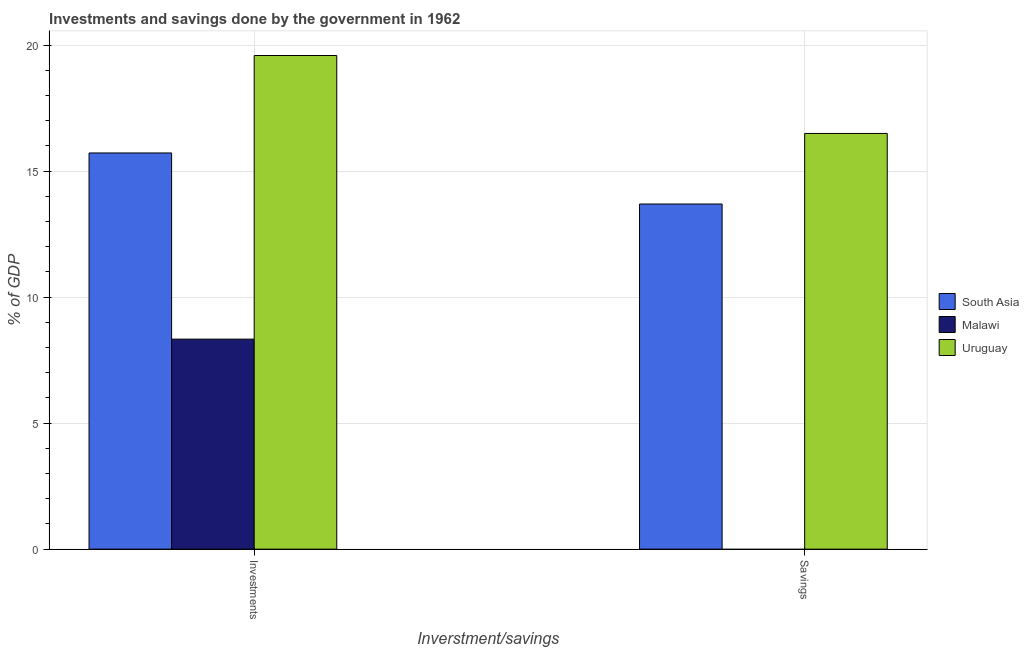How many different coloured bars are there?
Your response must be concise. 3. Are the number of bars per tick equal to the number of legend labels?
Keep it short and to the point. No. Are the number of bars on each tick of the X-axis equal?
Give a very brief answer. No. How many bars are there on the 2nd tick from the left?
Make the answer very short. 2. What is the label of the 2nd group of bars from the left?
Offer a terse response. Savings. What is the savings of government in Uruguay?
Your response must be concise. 16.49. Across all countries, what is the maximum savings of government?
Make the answer very short. 16.49. Across all countries, what is the minimum savings of government?
Provide a succinct answer. 0. In which country was the savings of government maximum?
Provide a short and direct response. Uruguay. What is the total savings of government in the graph?
Your answer should be very brief. 30.19. What is the difference between the investments of government in Uruguay and that in South Asia?
Ensure brevity in your answer.  3.87. What is the difference between the investments of government in Malawi and the savings of government in South Asia?
Provide a succinct answer. -5.36. What is the average savings of government per country?
Keep it short and to the point. 10.06. What is the difference between the investments of government and savings of government in Uruguay?
Your answer should be compact. 3.09. In how many countries, is the investments of government greater than 5 %?
Offer a very short reply. 3. What is the ratio of the investments of government in Uruguay to that in South Asia?
Offer a terse response. 1.25. In how many countries, is the savings of government greater than the average savings of government taken over all countries?
Ensure brevity in your answer.  2. What is the difference between two consecutive major ticks on the Y-axis?
Ensure brevity in your answer.  5. Does the graph contain grids?
Keep it short and to the point. Yes. What is the title of the graph?
Your answer should be compact. Investments and savings done by the government in 1962. What is the label or title of the X-axis?
Keep it short and to the point. Inverstment/savings. What is the label or title of the Y-axis?
Provide a succinct answer. % of GDP. What is the % of GDP in South Asia in Investments?
Give a very brief answer. 15.72. What is the % of GDP of Malawi in Investments?
Provide a succinct answer. 8.33. What is the % of GDP of Uruguay in Investments?
Your response must be concise. 19.59. What is the % of GDP of South Asia in Savings?
Provide a short and direct response. 13.69. What is the % of GDP in Malawi in Savings?
Provide a succinct answer. 0. What is the % of GDP of Uruguay in Savings?
Make the answer very short. 16.49. Across all Inverstment/savings, what is the maximum % of GDP of South Asia?
Ensure brevity in your answer.  15.72. Across all Inverstment/savings, what is the maximum % of GDP in Malawi?
Ensure brevity in your answer.  8.33. Across all Inverstment/savings, what is the maximum % of GDP of Uruguay?
Keep it short and to the point. 19.59. Across all Inverstment/savings, what is the minimum % of GDP in South Asia?
Your answer should be very brief. 13.69. Across all Inverstment/savings, what is the minimum % of GDP of Malawi?
Ensure brevity in your answer.  0. Across all Inverstment/savings, what is the minimum % of GDP in Uruguay?
Make the answer very short. 16.49. What is the total % of GDP of South Asia in the graph?
Provide a succinct answer. 29.42. What is the total % of GDP of Malawi in the graph?
Your answer should be very brief. 8.33. What is the total % of GDP of Uruguay in the graph?
Your answer should be very brief. 36.08. What is the difference between the % of GDP in South Asia in Investments and that in Savings?
Offer a very short reply. 2.03. What is the difference between the % of GDP in Uruguay in Investments and that in Savings?
Provide a succinct answer. 3.09. What is the difference between the % of GDP in South Asia in Investments and the % of GDP in Uruguay in Savings?
Offer a terse response. -0.77. What is the difference between the % of GDP of Malawi in Investments and the % of GDP of Uruguay in Savings?
Offer a terse response. -8.16. What is the average % of GDP in South Asia per Inverstment/savings?
Provide a short and direct response. 14.71. What is the average % of GDP of Malawi per Inverstment/savings?
Your response must be concise. 4.17. What is the average % of GDP in Uruguay per Inverstment/savings?
Provide a short and direct response. 18.04. What is the difference between the % of GDP of South Asia and % of GDP of Malawi in Investments?
Offer a very short reply. 7.39. What is the difference between the % of GDP of South Asia and % of GDP of Uruguay in Investments?
Give a very brief answer. -3.87. What is the difference between the % of GDP in Malawi and % of GDP in Uruguay in Investments?
Keep it short and to the point. -11.25. What is the difference between the % of GDP of South Asia and % of GDP of Uruguay in Savings?
Offer a terse response. -2.8. What is the ratio of the % of GDP of South Asia in Investments to that in Savings?
Ensure brevity in your answer.  1.15. What is the ratio of the % of GDP in Uruguay in Investments to that in Savings?
Provide a succinct answer. 1.19. What is the difference between the highest and the second highest % of GDP of South Asia?
Ensure brevity in your answer.  2.03. What is the difference between the highest and the second highest % of GDP of Uruguay?
Provide a succinct answer. 3.09. What is the difference between the highest and the lowest % of GDP of South Asia?
Give a very brief answer. 2.03. What is the difference between the highest and the lowest % of GDP in Malawi?
Provide a succinct answer. 8.33. What is the difference between the highest and the lowest % of GDP in Uruguay?
Provide a succinct answer. 3.09. 